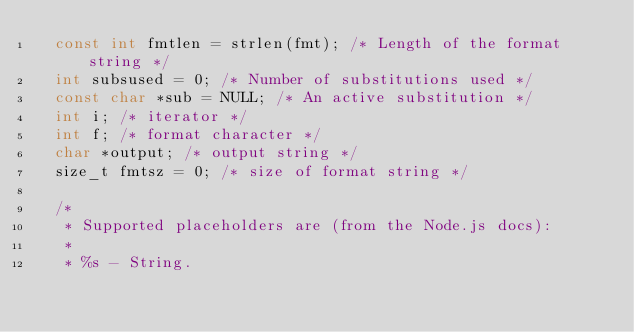Convert code to text. <code><loc_0><loc_0><loc_500><loc_500><_C_>	const int fmtlen = strlen(fmt); /* Length of the format string */
	int subsused = 0; /* Number of substitutions used */
	const char *sub = NULL; /* An active substitution */
	int i; /* iterator */
	int f; /* format character */
	char *output; /* output string */
	size_t fmtsz = 0; /* size of format string */
	
	/*
	 * Supported placeholders are (from the Node.js docs):
	 *
	 * %s - String.</code> 